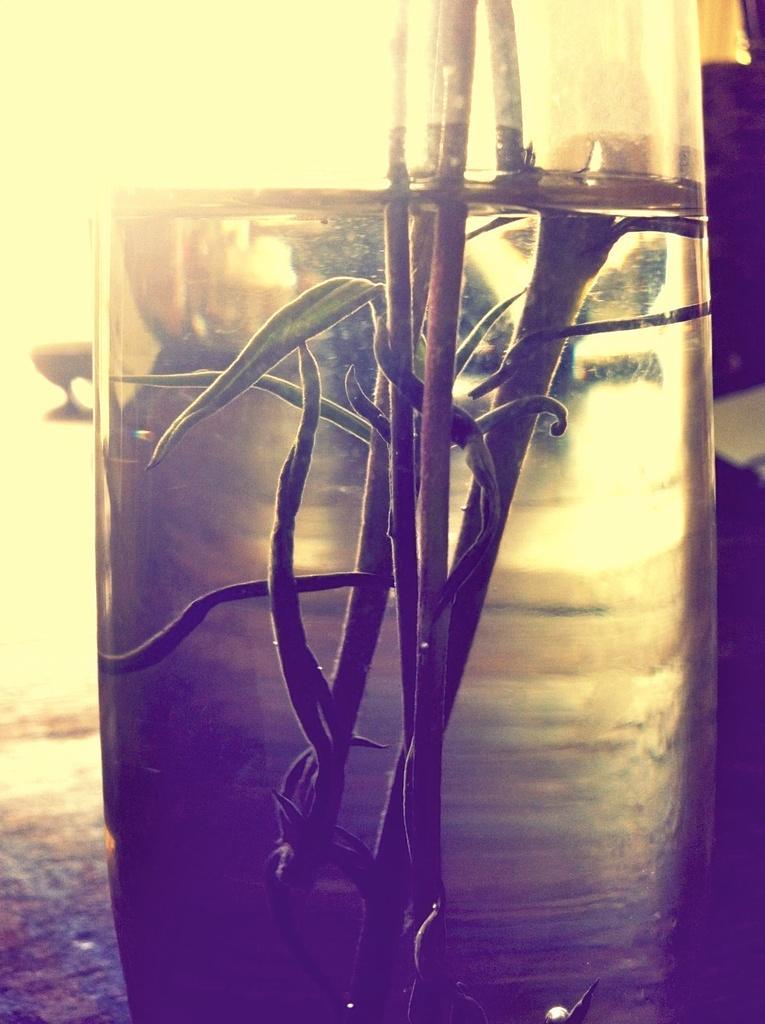Please provide a concise description of this image. In this image, I can see a glass of water. I think these are the stems with the leaves, which are in the water. The background looks blurry. 